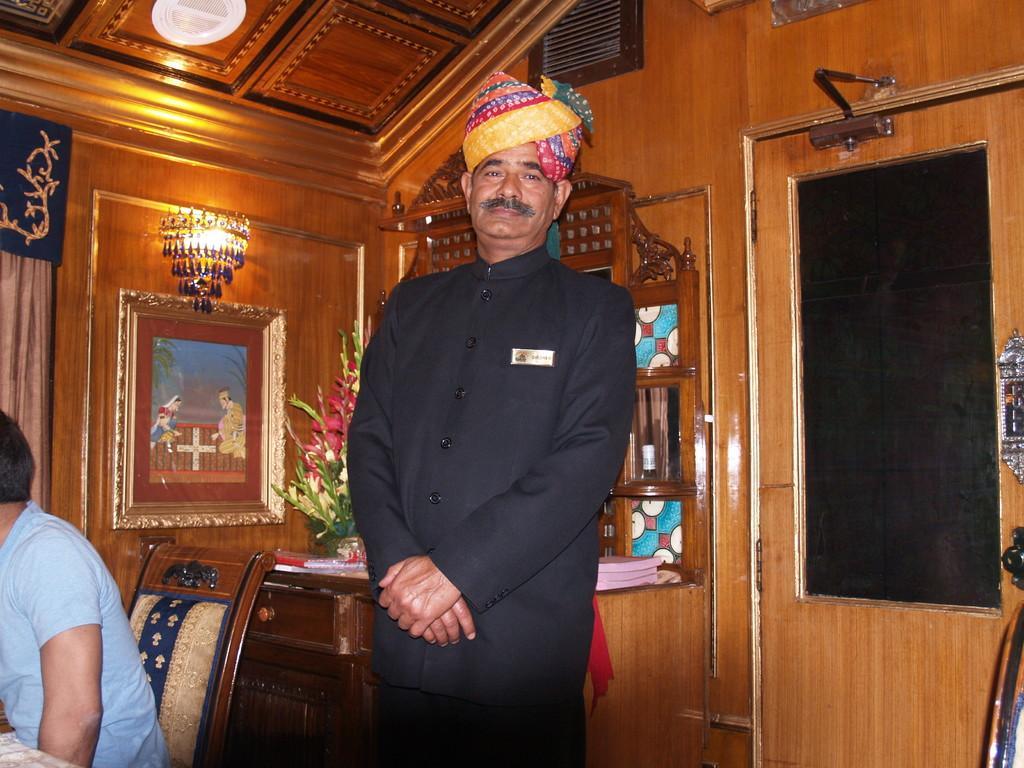In one or two sentences, can you explain what this image depicts? In this image we can see a man is standing. He is wearing a black color dress. In the background, we can see wooden wall, frame, light, table and chair. On the table, we can see books, flowers and some objects. There is a person sitting on the chair on the left side of the image. 